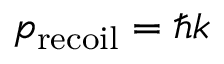Convert formula to latex. <formula><loc_0><loc_0><loc_500><loc_500>p _ { r e c o i l } = \hbar { k }</formula> 